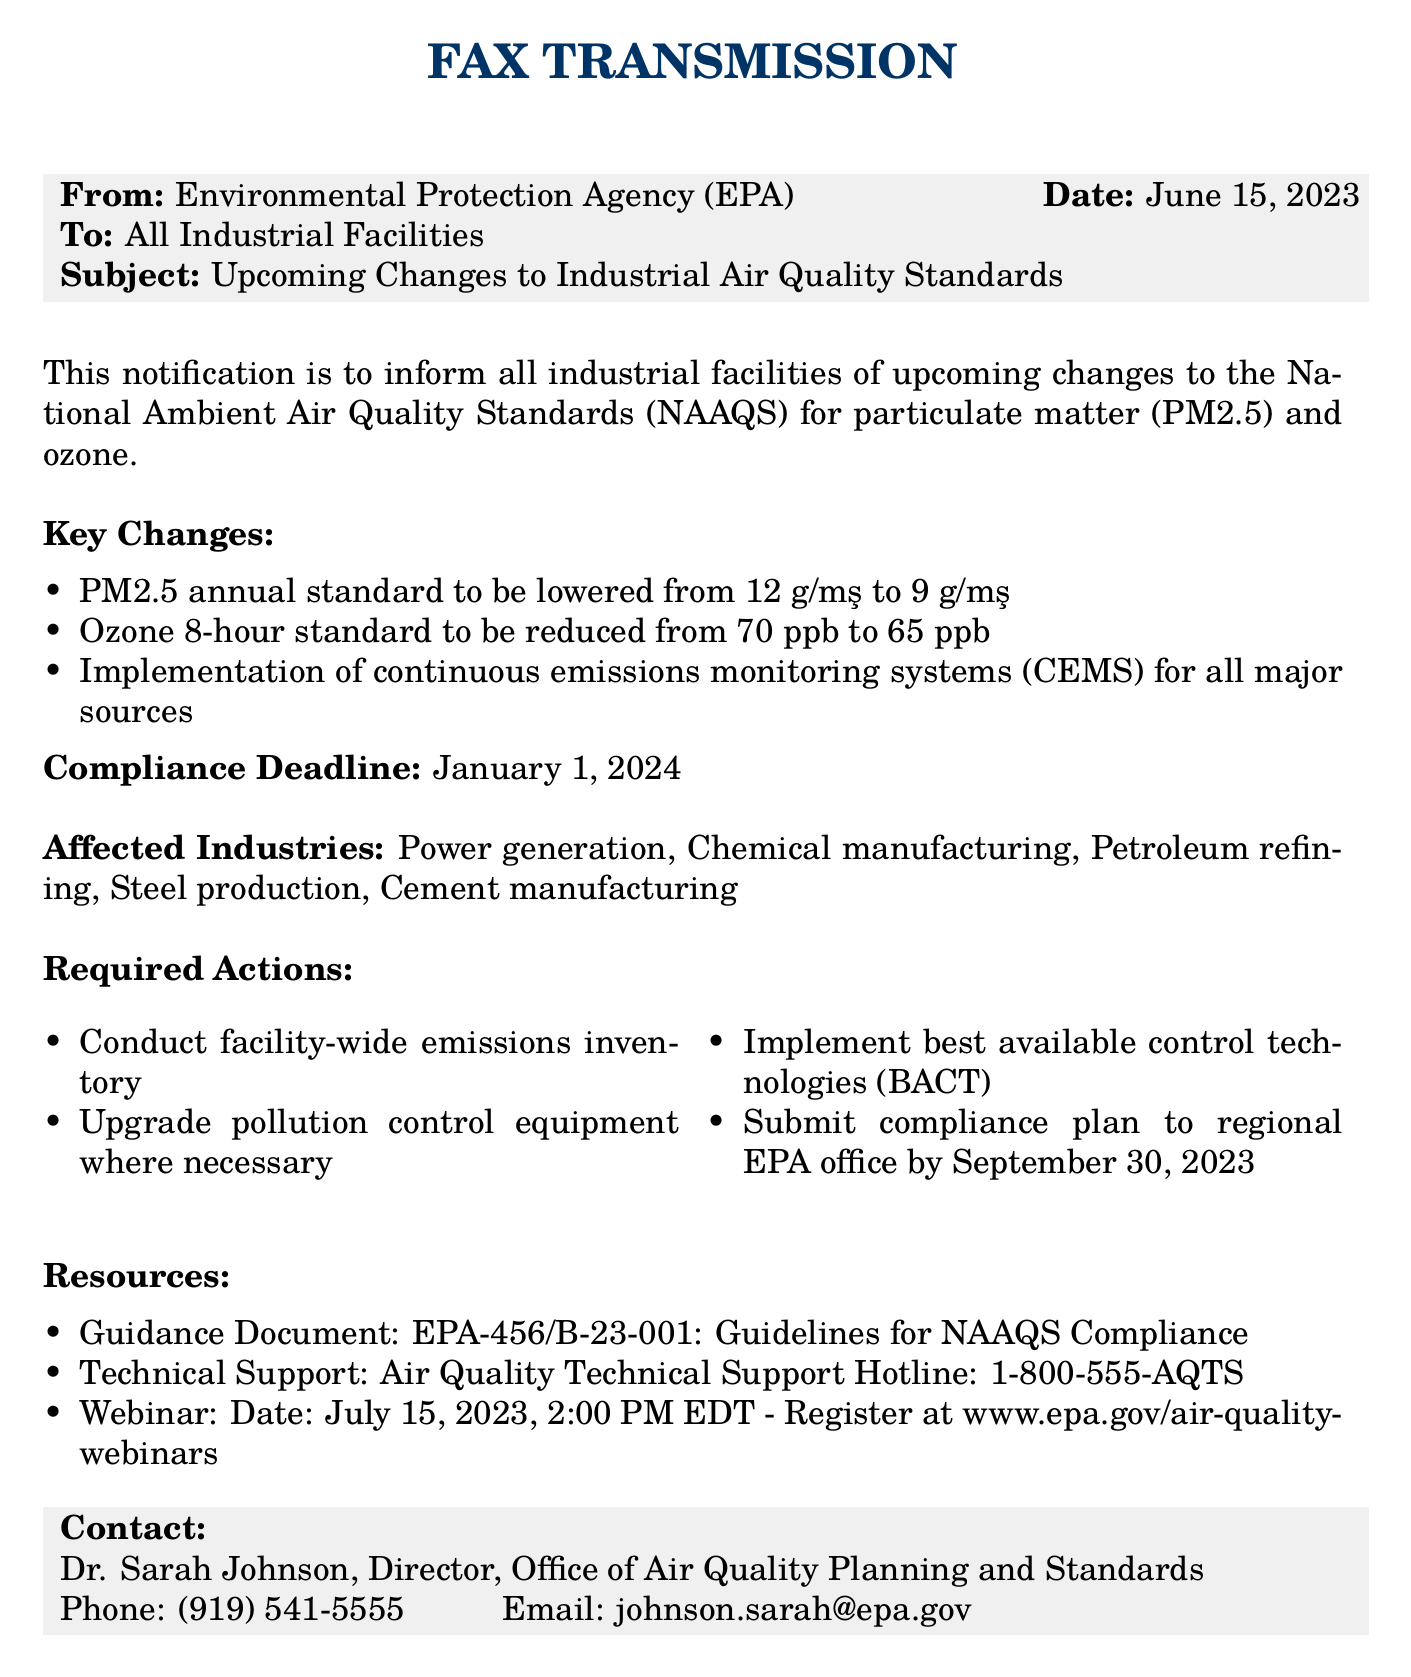What are the new PM2.5 annual standard values? The document states that the PM2.5 annual standard will be lowered from 12 μg/m³ to 9 μg/m³.
Answer: 9 μg/m³ What is the compliance deadline? The compliance deadline is explicitly mentioned in the document as January 1, 2024.
Answer: January 1, 2024 Who is the contact person for this notification? The document identifies Dr. Sarah Johnson as the contact person for the notification.
Answer: Dr. Sarah Johnson Which industries are affected by the upcoming changes? The document lists the affected industries including power generation, chemical manufacturing, petroleum refining, steel production, and cement manufacturing.
Answer: Power generation, Chemical manufacturing, Petroleum refining, Steel production, Cement manufacturing What is the date of the webinar? The document specifies the date of the webinar as July 15, 2023, at 2:00 PM EDT.
Answer: July 15, 2023 What standards are being lowered? The document mentions that the PM2.5 annual standard and the ozone 8-hour standard are being lowered.
Answer: PM2.5 and ozone What is the required action regarding emissions inventory? The document states that a facility-wide emissions inventory must be conducted as a required action.
Answer: Conduct facility-wide emissions inventory How can facilities get technical support? Technical support can be accessed via the Air Quality Technical Support Hotline as mentioned in the document.
Answer: 1-800-555-AQTS 